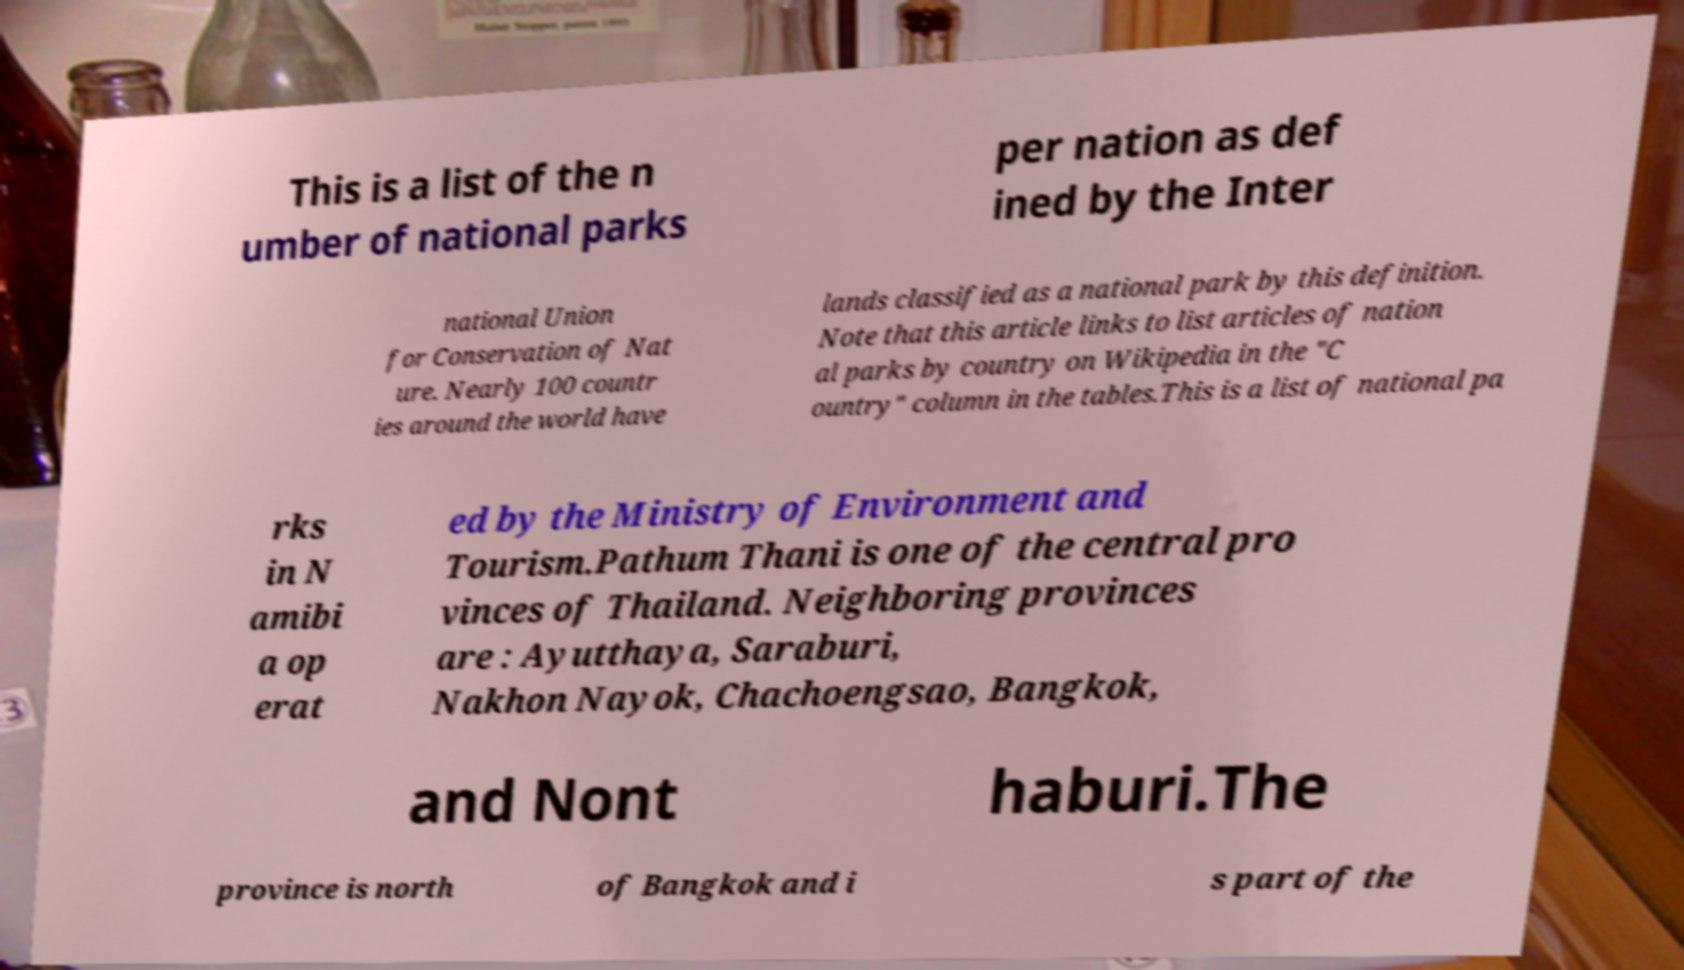What messages or text are displayed in this image? I need them in a readable, typed format. This is a list of the n umber of national parks per nation as def ined by the Inter national Union for Conservation of Nat ure. Nearly 100 countr ies around the world have lands classified as a national park by this definition. Note that this article links to list articles of nation al parks by country on Wikipedia in the "C ountry" column in the tables.This is a list of national pa rks in N amibi a op erat ed by the Ministry of Environment and Tourism.Pathum Thani is one of the central pro vinces of Thailand. Neighboring provinces are : Ayutthaya, Saraburi, Nakhon Nayok, Chachoengsao, Bangkok, and Nont haburi.The province is north of Bangkok and i s part of the 